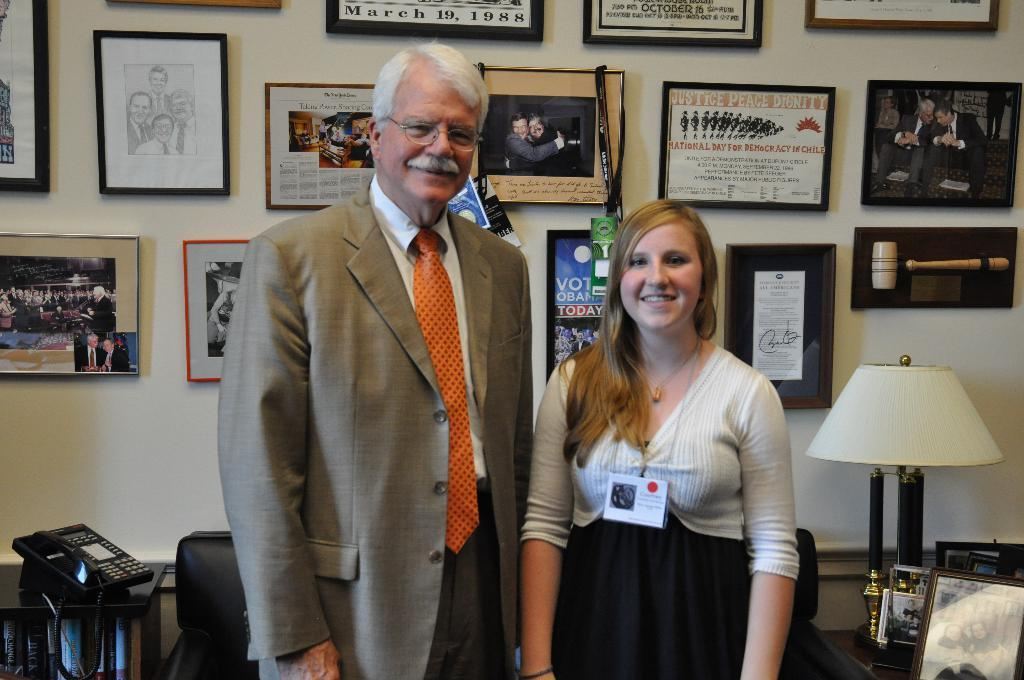<image>
Relay a brief, clear account of the picture shown. A certificsate behind two people posing for a photo refers to the country of Chile. 